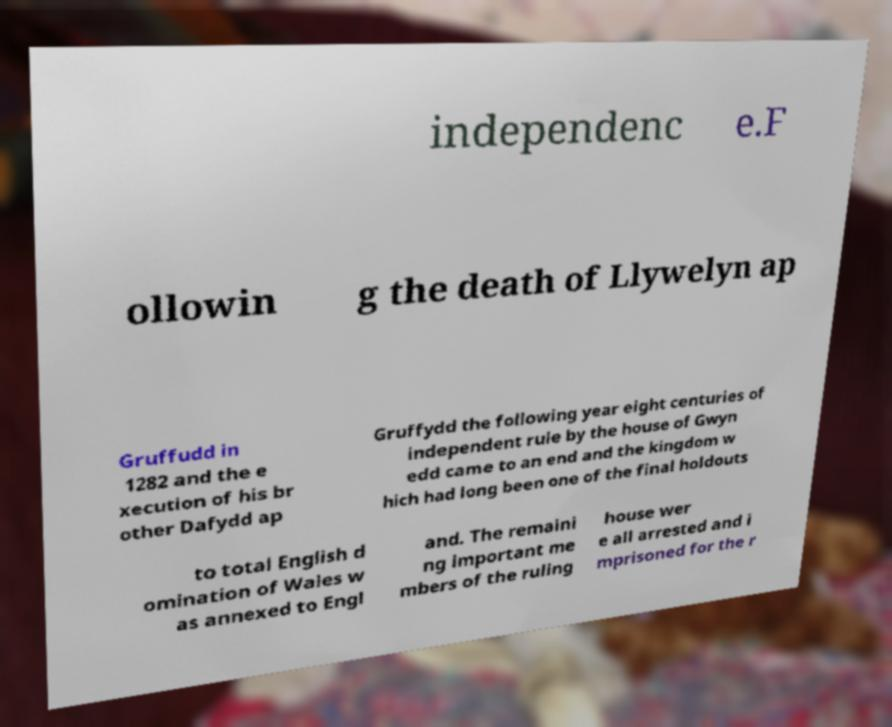There's text embedded in this image that I need extracted. Can you transcribe it verbatim? independenc e.F ollowin g the death of Llywelyn ap Gruffudd in 1282 and the e xecution of his br other Dafydd ap Gruffydd the following year eight centuries of independent rule by the house of Gwyn edd came to an end and the kingdom w hich had long been one of the final holdouts to total English d omination of Wales w as annexed to Engl and. The remaini ng important me mbers of the ruling house wer e all arrested and i mprisoned for the r 